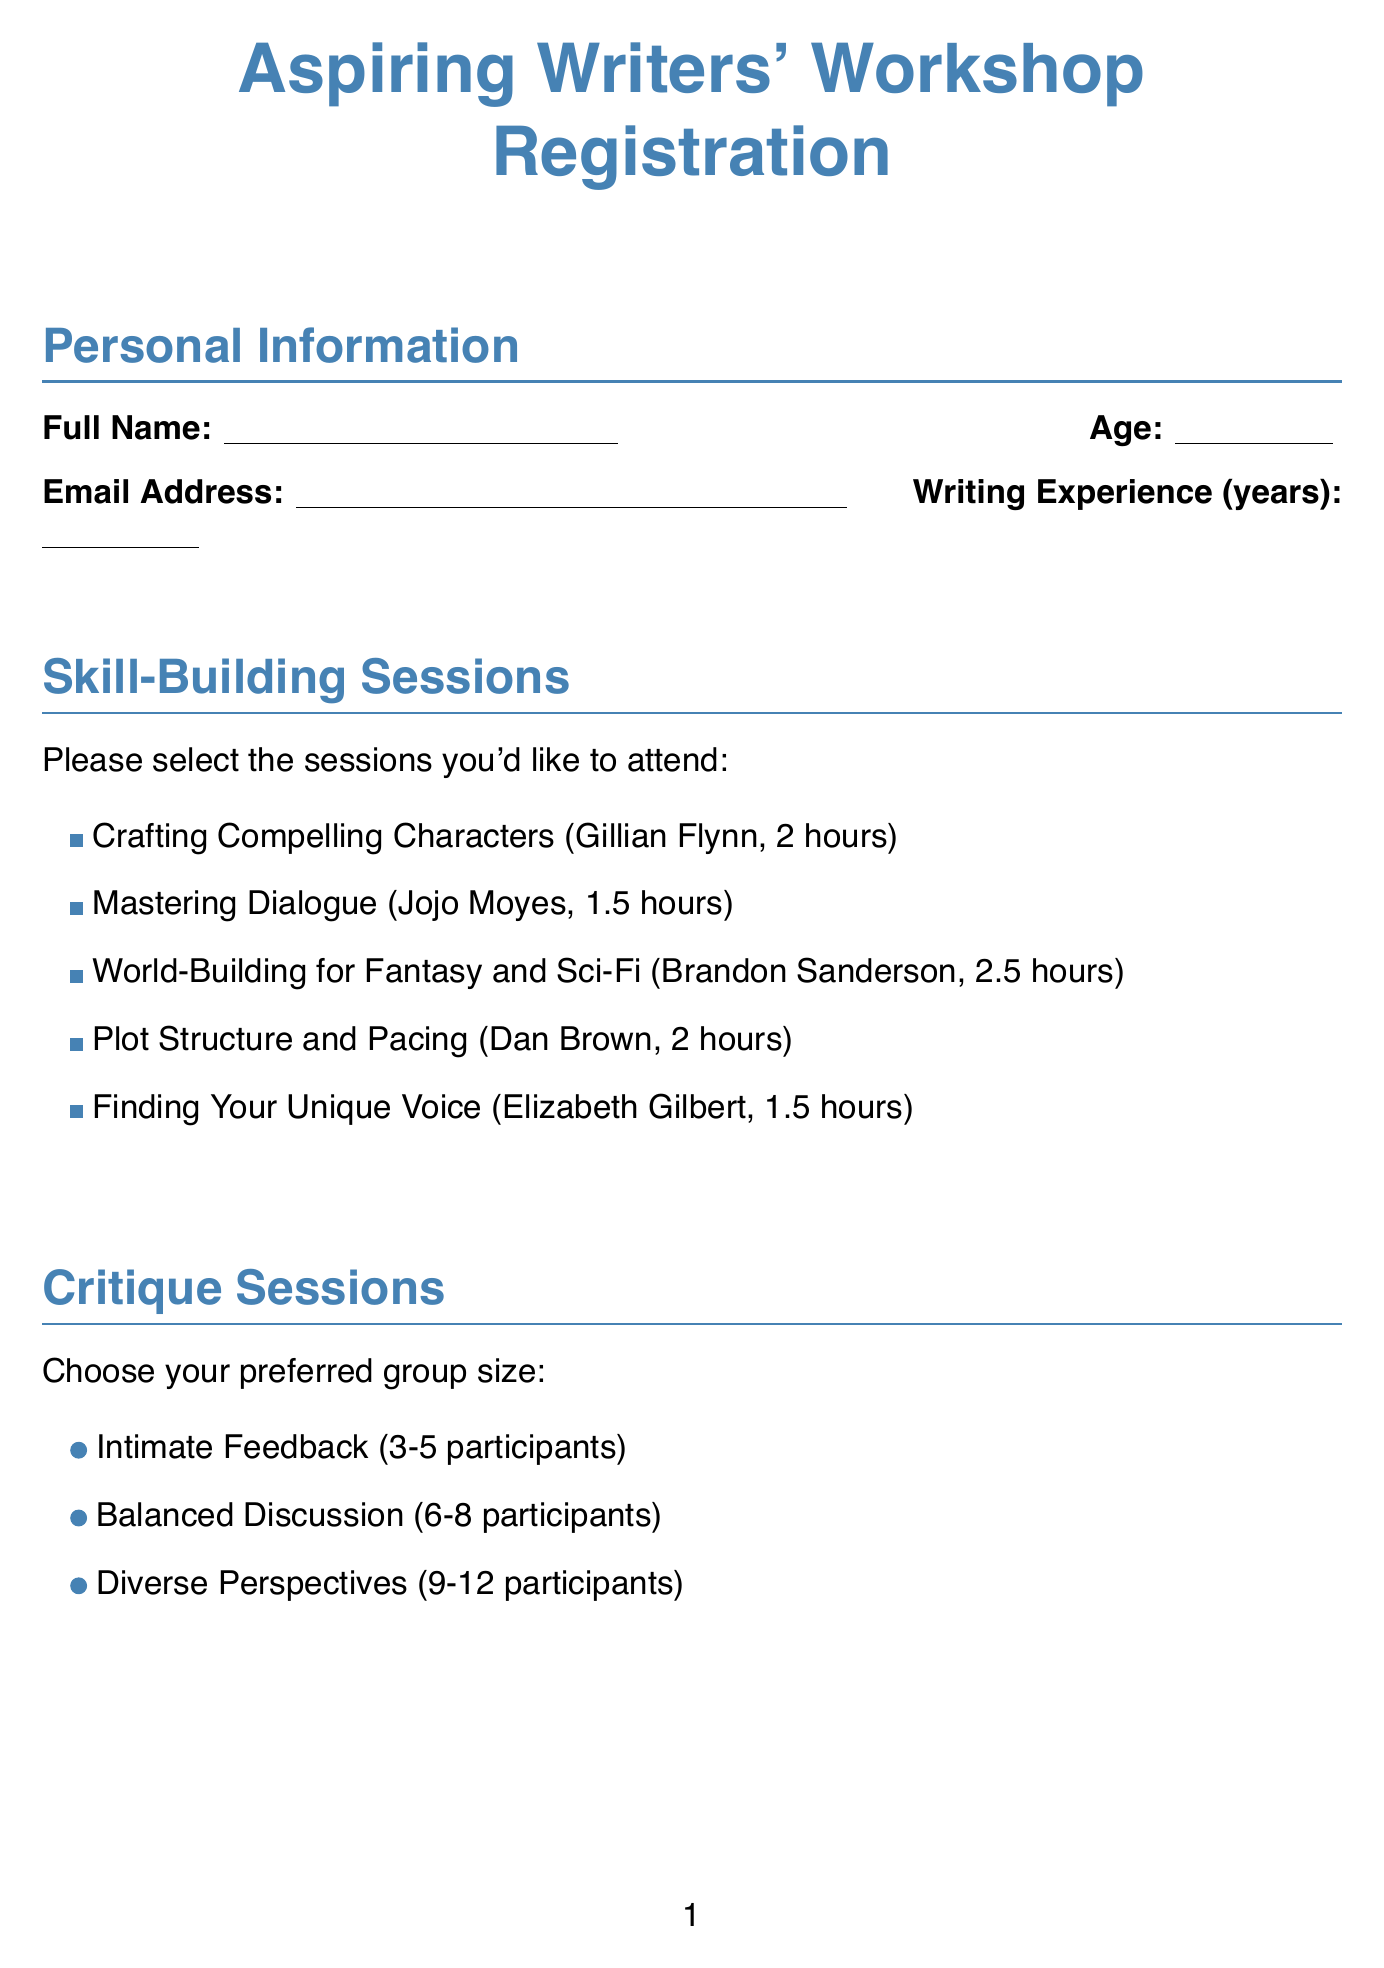What is the title of the workshop? The title of the workshop is listed at the top of the document.
Answer: Aspiring Writers' Workshop Registration Who is the instructor for "World-Building for Fantasy and Sci-Fi"? The document contains a section listing the instructors for each skill-building session.
Answer: Brandon Sanderson What is the date of the workshop? The date is provided in the Workshop Details section of the document.
Answer: August 15-17, 2023 How long is the "Mastering Dialogue" session? The duration of each skill-building session is included in the corresponding listing.
Answer: 1.5 hours What is the maximum group size for the "Diverse Perspectives" critique session? The document specifies the group sizes for the critique sessions.
Answer: 12 participants What is the early bird discount percentage? The early bird discount is mentioned in the Workshop Details section.
Answer: 15% off What is the primary genre option that is NOT listed? The dropdown options in the document should be checked for genres.
Answer: Mystery Have any alumni given testimonials about the workshop? The testimonials section includes quotes from past participants about their experiences.
Answer: Yes 